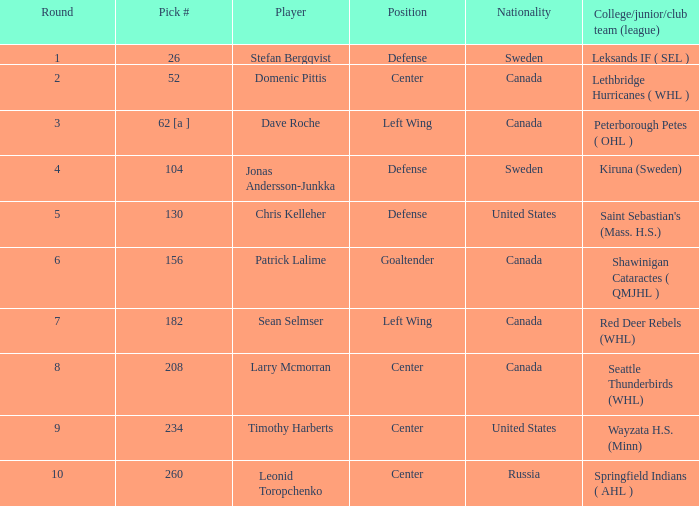Write the full table. {'header': ['Round', 'Pick #', 'Player', 'Position', 'Nationality', 'College/junior/club team (league)'], 'rows': [['1', '26', 'Stefan Bergqvist', 'Defense', 'Sweden', 'Leksands IF ( SEL )'], ['2', '52', 'Domenic Pittis', 'Center', 'Canada', 'Lethbridge Hurricanes ( WHL )'], ['3', '62 [a ]', 'Dave Roche', 'Left Wing', 'Canada', 'Peterborough Petes ( OHL )'], ['4', '104', 'Jonas Andersson-Junkka', 'Defense', 'Sweden', 'Kiruna (Sweden)'], ['5', '130', 'Chris Kelleher', 'Defense', 'United States', "Saint Sebastian's (Mass. H.S.)"], ['6', '156', 'Patrick Lalime', 'Goaltender', 'Canada', 'Shawinigan Cataractes ( QMJHL )'], ['7', '182', 'Sean Selmser', 'Left Wing', 'Canada', 'Red Deer Rebels (WHL)'], ['8', '208', 'Larry Mcmorran', 'Center', 'Canada', 'Seattle Thunderbirds (WHL)'], ['9', '234', 'Timothy Harberts', 'Center', 'United States', 'Wayzata H.S. (Minn)'], ['10', '260', 'Leonid Toropchenko', 'Center', 'Russia', 'Springfield Indians ( AHL )']]} Which country does the player representing seattle thunderbirds (whl) come from? Canada. 